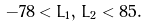Convert formula to latex. <formula><loc_0><loc_0><loc_500><loc_500>- 7 8 < L _ { 1 } , \, L _ { 2 } < 8 5 .</formula> 